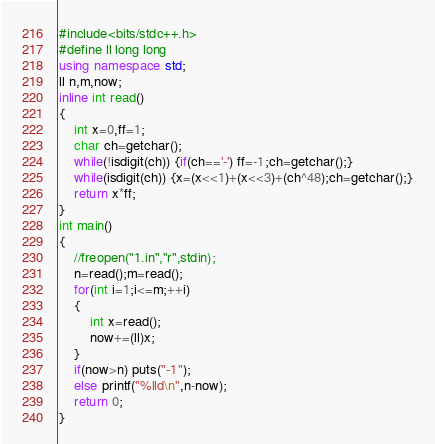<code> <loc_0><loc_0><loc_500><loc_500><_C++_>#include<bits/stdc++.h>
#define ll long long
using namespace std;
ll n,m,now;
inline int read()
{
	int x=0,ff=1;
	char ch=getchar();
	while(!isdigit(ch)) {if(ch=='-') ff=-1;ch=getchar();}
	while(isdigit(ch)) {x=(x<<1)+(x<<3)+(ch^48);ch=getchar();}
	return x*ff;
}
int main()
{
	//freopen("1.in","r",stdin);
	n=read();m=read();
	for(int i=1;i<=m;++i) 
	{
		int x=read();
		now+=(ll)x;
	}
	if(now>n) puts("-1");
	else printf("%lld\n",n-now);
	return 0;
}
</code> 